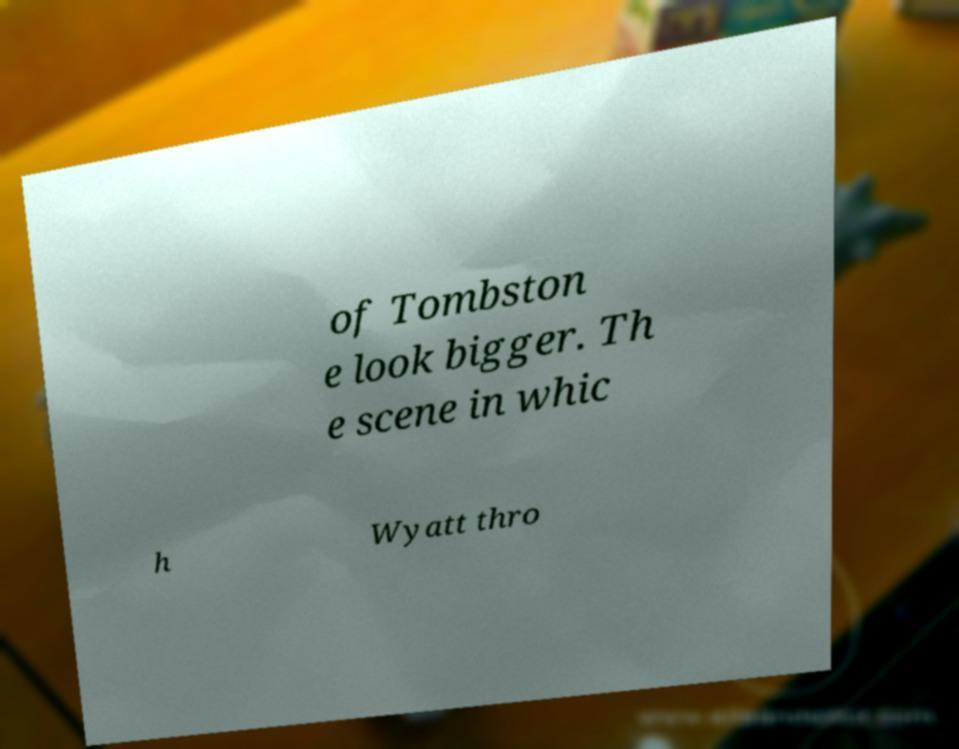What messages or text are displayed in this image? I need them in a readable, typed format. of Tombston e look bigger. Th e scene in whic h Wyatt thro 